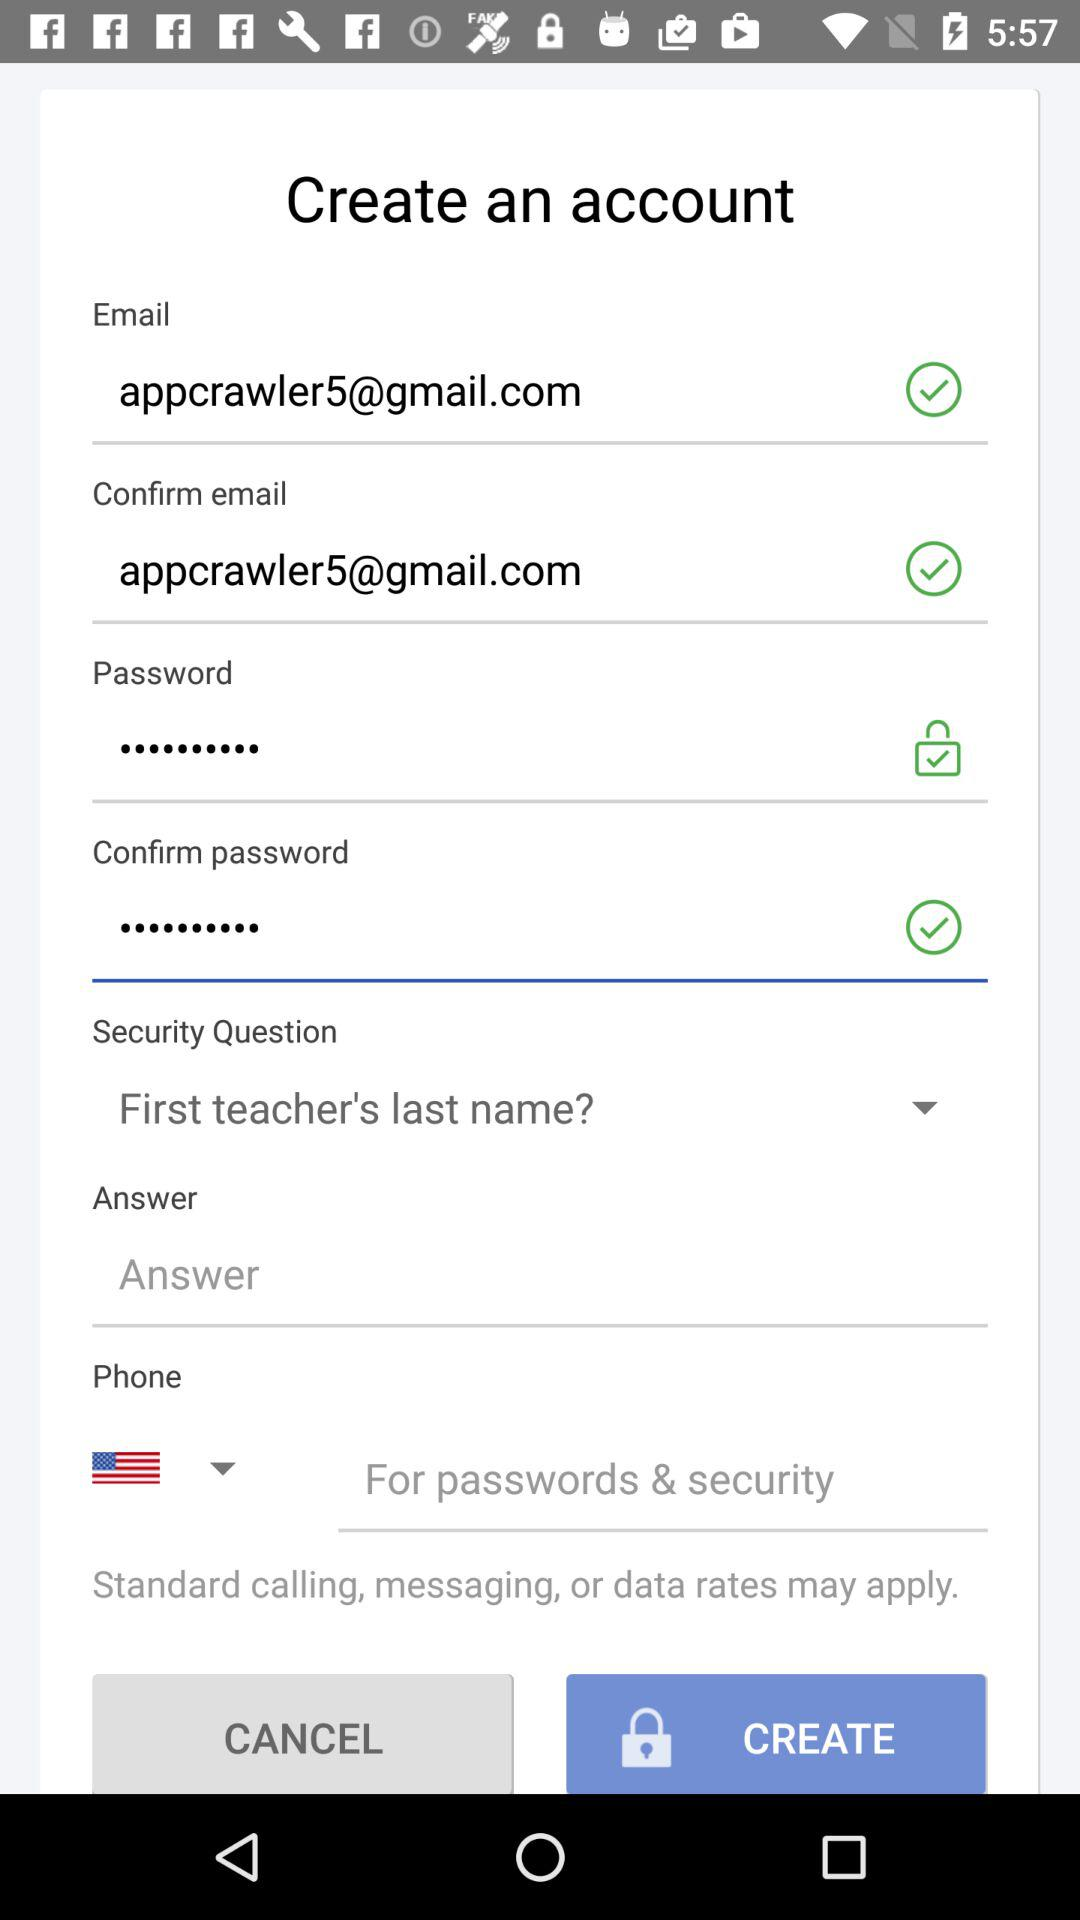What is the security question? The security question is "First teacher's last name?". 